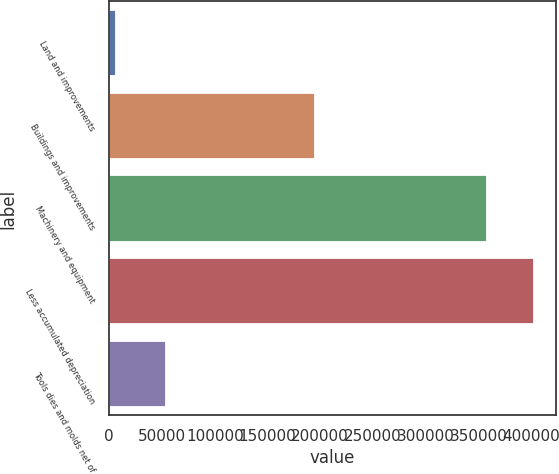Convert chart to OTSL. <chart><loc_0><loc_0><loc_500><loc_500><bar_chart><fcel>Land and improvements<fcel>Buildings and improvements<fcel>Machinery and equipment<fcel>Less accumulated depreciation<fcel>Tools dies and molds net of<nl><fcel>6578<fcel>195520<fcel>358529<fcel>403082<fcel>54162<nl></chart> 